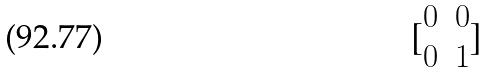Convert formula to latex. <formula><loc_0><loc_0><loc_500><loc_500>[ \begin{matrix} 0 & 0 \\ 0 & 1 \end{matrix} ]</formula> 